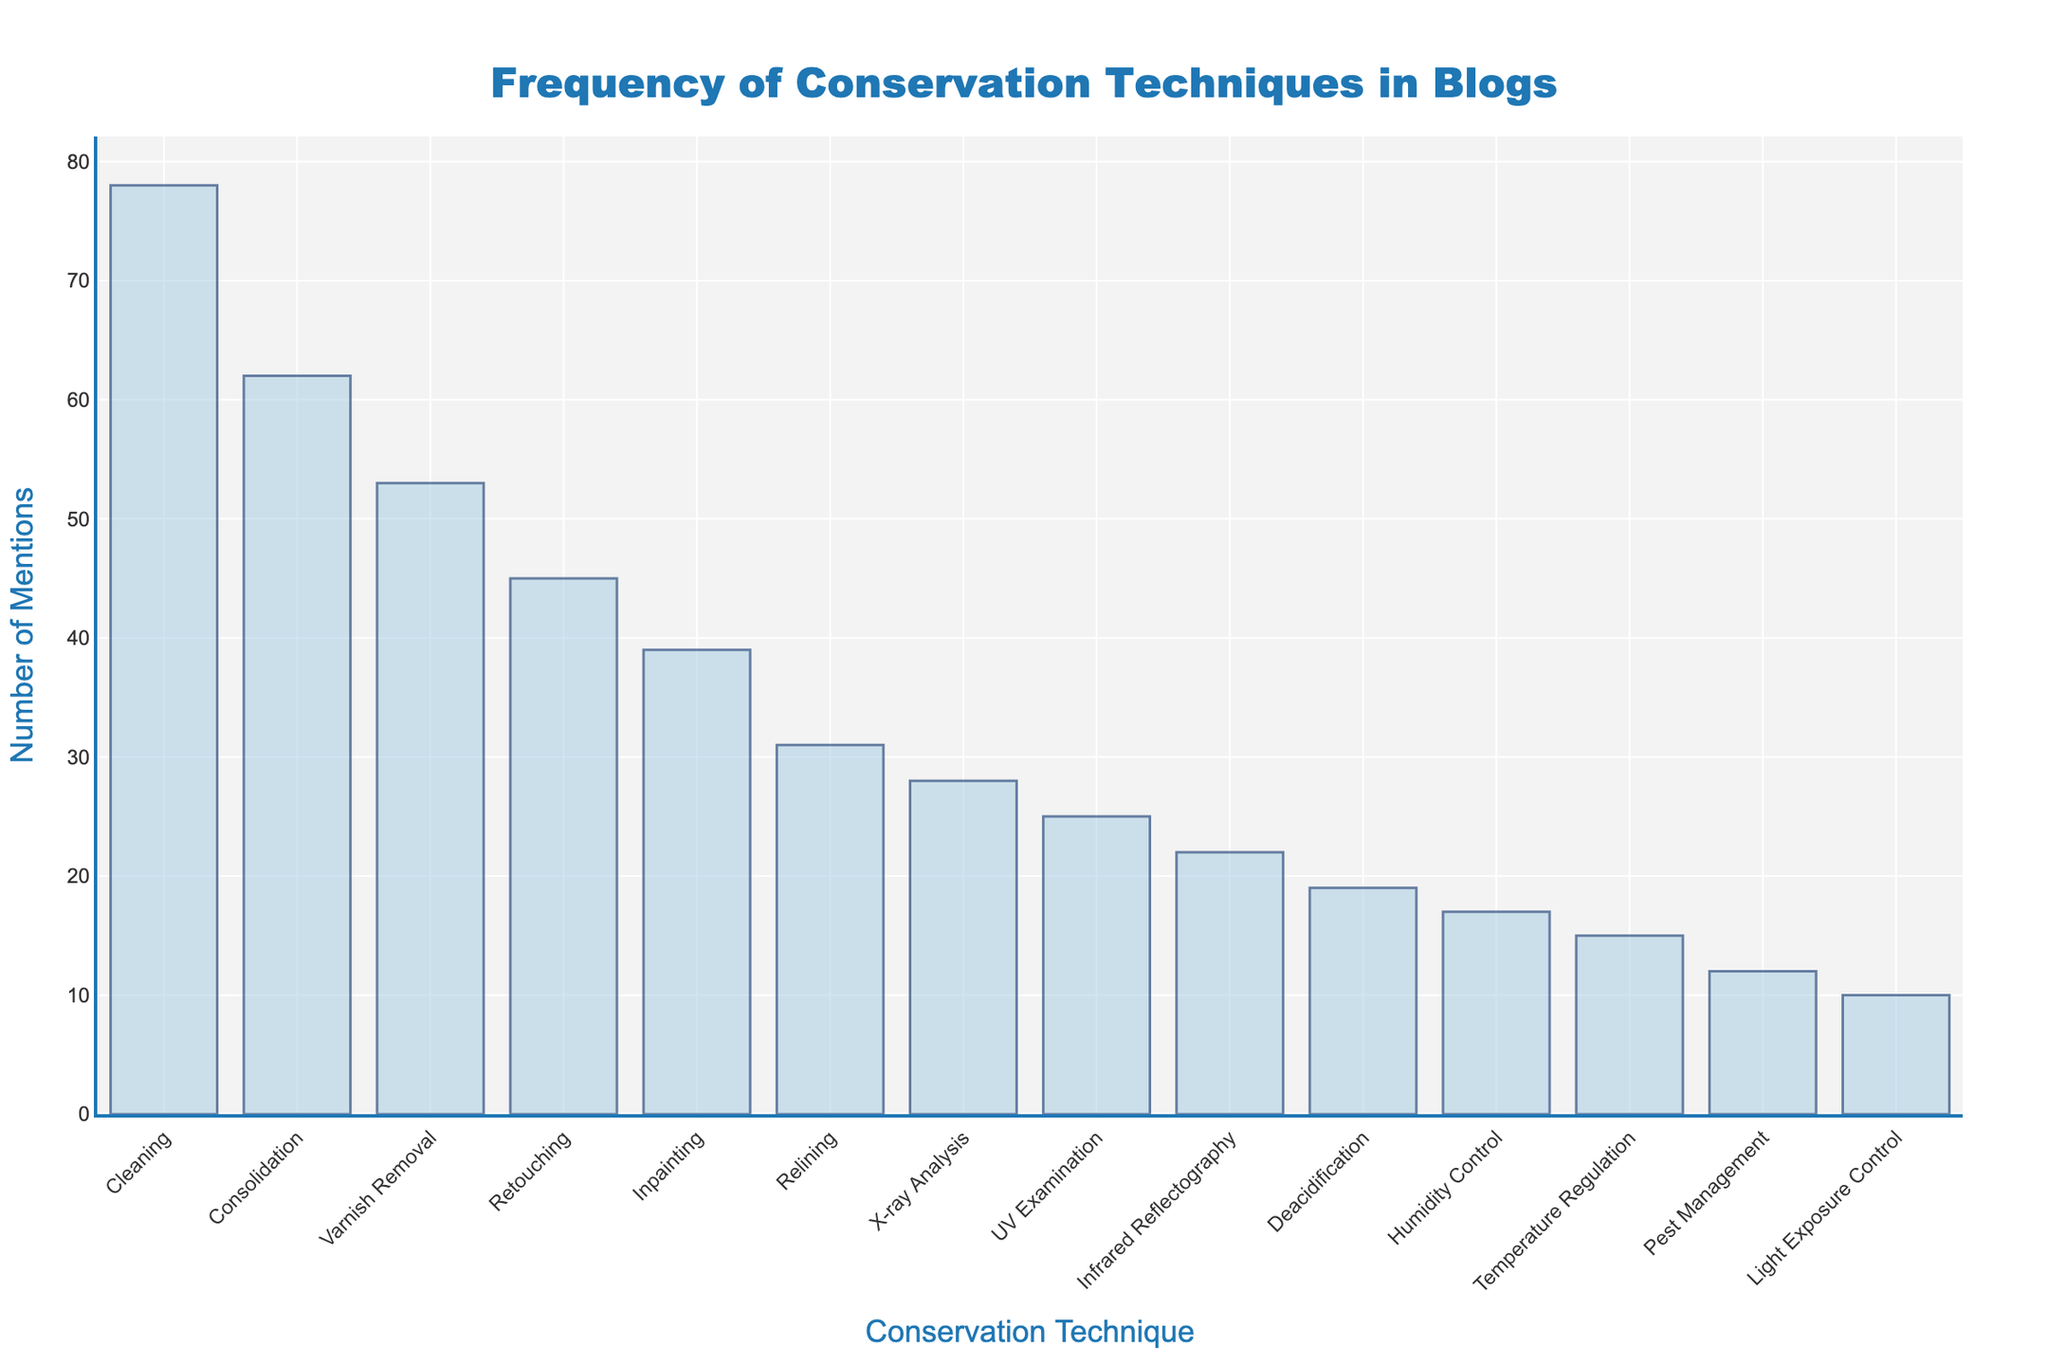What is the title of the histogram? The title is displayed at the top of the figure and is centered. It reads: "Frequency of Conservation Techniques in Blogs".
Answer: Frequency of Conservation Techniques in Blogs Which conservation technique has the highest number of mentions? The bar for "Cleaning" is the tallest one, indicating it has the highest number of mentions.
Answer: Cleaning How many conservation techniques have more than 50 mentions? Observing the bars, "Cleaning", "Consolidation", and "Varnish Removal" have bars extending beyond the 50 mark. Thus, there are 3 techniques.
Answer: 3 What is the total number of mentions for "Relining" and "UV Examination"? The exact counts are listed next to each technique. Adding them, "Relining" has 31 mentions and "UV Examination" has 25 mentions, so the total is 31 + 25 = 56.
Answer: 56 How many mentions separate "Temperature Regulation" from "Humidity Control"? "Humidity Control" has 17 mentions, and "Temperature Regulation" has 15 mentions. The difference is 17 - 15 = 2 mentions.
Answer: 2 Which technique is mentioned the least often? The shortest bar corresponds to "Light Exposure Control", indicating it has the least mentions.
Answer: Light Exposure Control Between "X-ray Analysis" and "Infrared Reflectography", which technique is mentioned more frequently? Comparing the length of the bars, "X-ray Analysis" has 28 mentions while "Infrared Reflectography" has 22 mentions. Thus, "X-ray Analysis" has more mentions.
Answer: X-ray Analysis Are there more techniques with fewer than 20 mentions or more than 20 mentions? Counting the bars below and above the 20-mention line: fewer than 20 mentions ("Deacidification", "Humidity Control", "Temperature Regulation", "Pest Management", "Light Exposure Control")—5 techniques; more than 20 mentions ("Cleaning", "Consolidation", "Varnish Removal", "Retouching", "Inpainting", "Relining", "X-ray Analysis", "UV Examination", "Infrared Reflectography")—9 techniques. So, more techniques have more than 20 mentions.
Answer: More techniques have more than 20 mentions How many techniques are mentioned exactly 39 times? The exact value of 39 mentions corresponds to just one technique, "Inpainting".
Answer: 1 What's the range in the number of mentions across all techniques? The highest number of mentions is for "Cleaning" with 78, and the lowest is "Light Exposure Control" with 10. The range is 78 - 10 = 68.
Answer: 68 